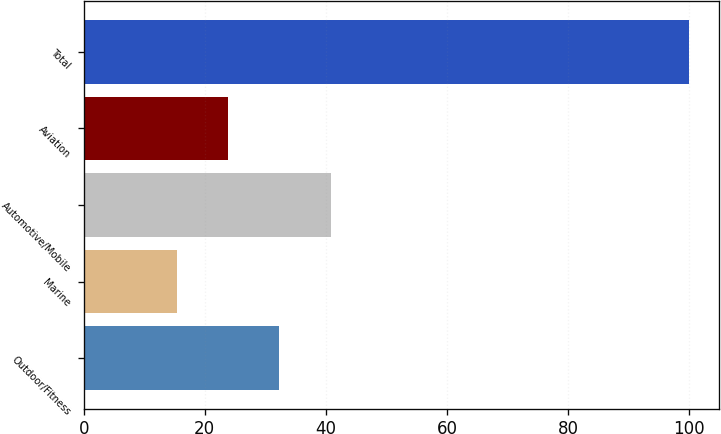Convert chart to OTSL. <chart><loc_0><loc_0><loc_500><loc_500><bar_chart><fcel>Outdoor/Fitness<fcel>Marine<fcel>Automotive/Mobile<fcel>Aviation<fcel>Total<nl><fcel>32.32<fcel>15.4<fcel>40.78<fcel>23.86<fcel>100<nl></chart> 